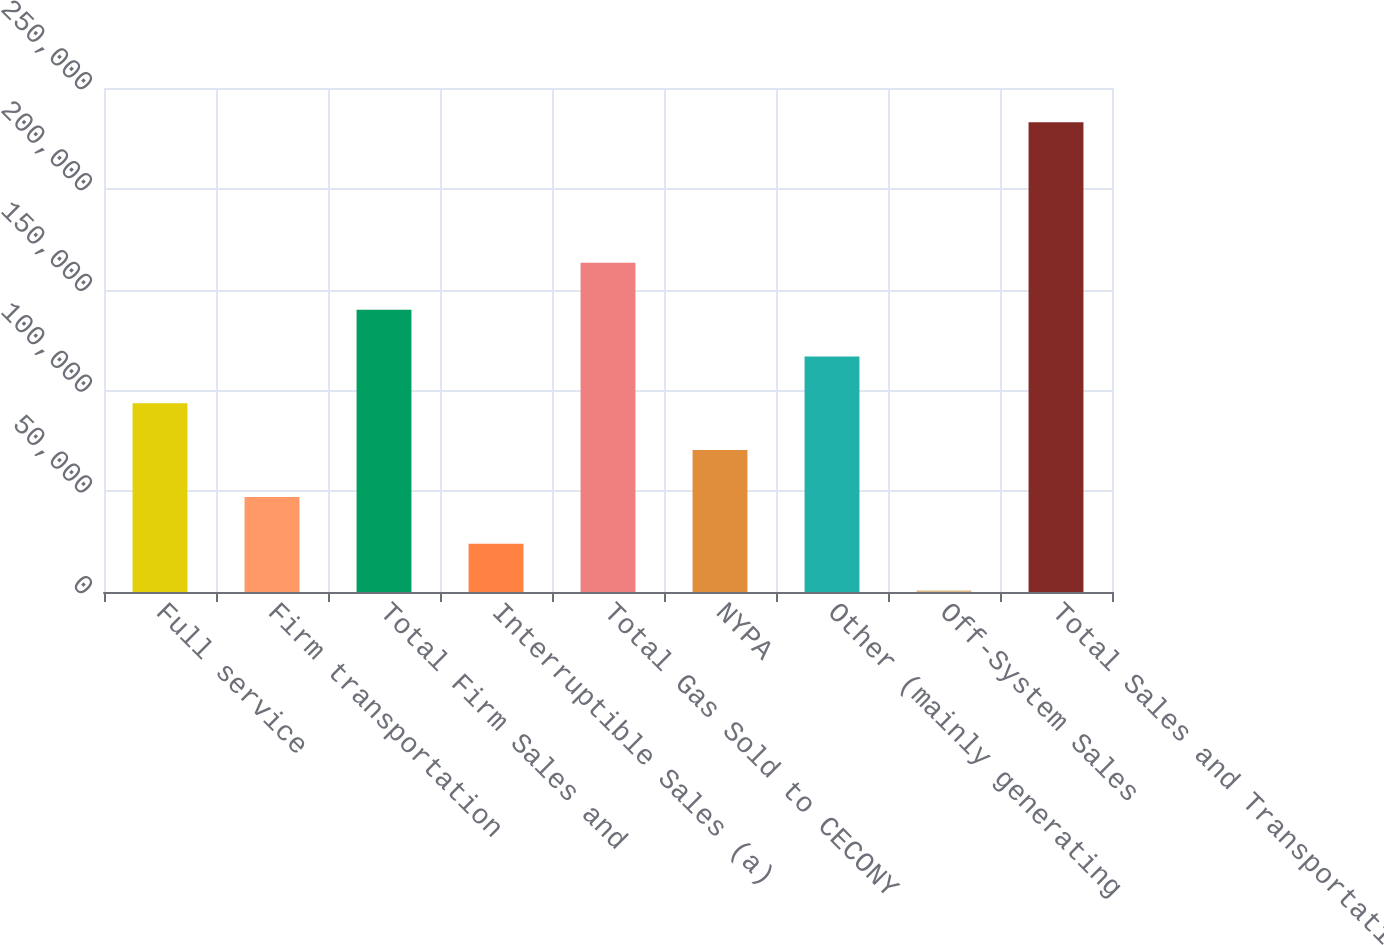Convert chart to OTSL. <chart><loc_0><loc_0><loc_500><loc_500><bar_chart><fcel>Full service<fcel>Firm transportation<fcel>Total Firm Sales and<fcel>Interruptible Sales (a)<fcel>Total Gas Sold to CECONY<fcel>NYPA<fcel>Other (mainly generating<fcel>Off-System Sales<fcel>Total Sales and Transportation<nl><fcel>93605.4<fcel>47148.2<fcel>140063<fcel>23919.6<fcel>163291<fcel>70376.8<fcel>116834<fcel>691<fcel>232977<nl></chart> 